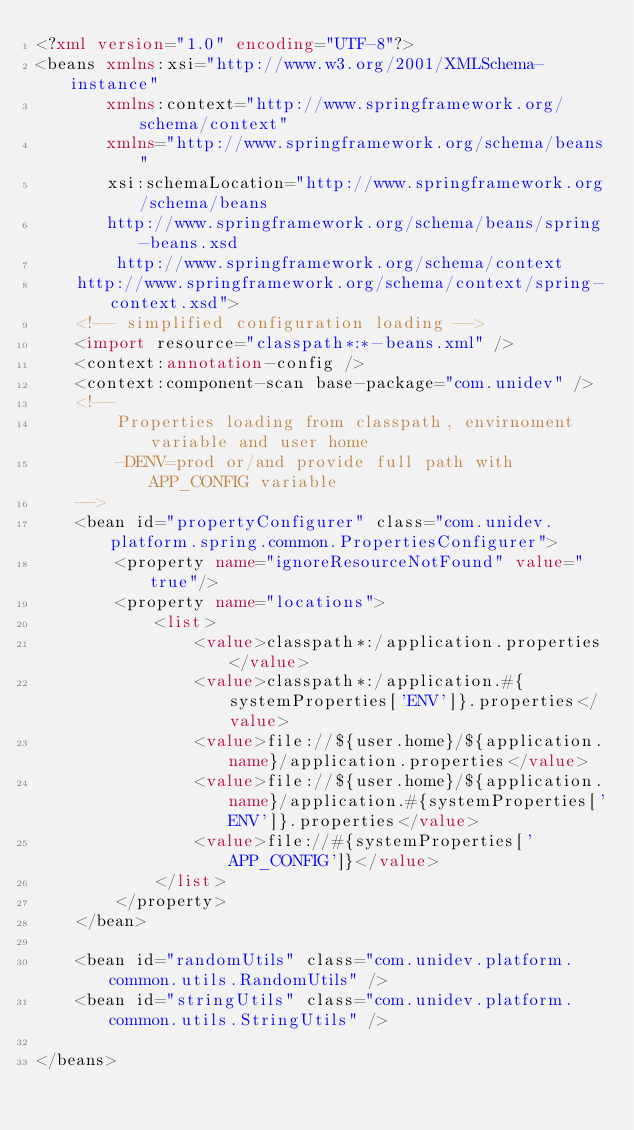<code> <loc_0><loc_0><loc_500><loc_500><_XML_><?xml version="1.0" encoding="UTF-8"?>
<beans xmlns:xsi="http://www.w3.org/2001/XMLSchema-instance"
       xmlns:context="http://www.springframework.org/schema/context"
       xmlns="http://www.springframework.org/schema/beans"
       xsi:schemaLocation="http://www.springframework.org/schema/beans
       http://www.springframework.org/schema/beans/spring-beans.xsd
        http://www.springframework.org/schema/context
    http://www.springframework.org/schema/context/spring-context.xsd">
    <!-- simplified configuration loading -->
    <import resource="classpath*:*-beans.xml" />
    <context:annotation-config />
    <context:component-scan base-package="com.unidev" />
    <!--
        Properties loading from classpath, envirnoment variable and user home
        -DENV=prod or/and provide full path with APP_CONFIG variable
    -->
    <bean id="propertyConfigurer" class="com.unidev.platform.spring.common.PropertiesConfigurer">
        <property name="ignoreResourceNotFound" value="true"/>
        <property name="locations">
            <list>
                <value>classpath*:/application.properties</value>
                <value>classpath*:/application.#{systemProperties['ENV']}.properties</value>
                <value>file://${user.home}/${application.name}/application.properties</value>
                <value>file://${user.home}/${application.name}/application.#{systemProperties['ENV']}.properties</value>
                <value>file://#{systemProperties['APP_CONFIG']}</value>
            </list>
        </property>
    </bean>

    <bean id="randomUtils" class="com.unidev.platform.common.utils.RandomUtils" />
    <bean id="stringUtils" class="com.unidev.platform.common.utils.StringUtils" />

</beans>
</code> 